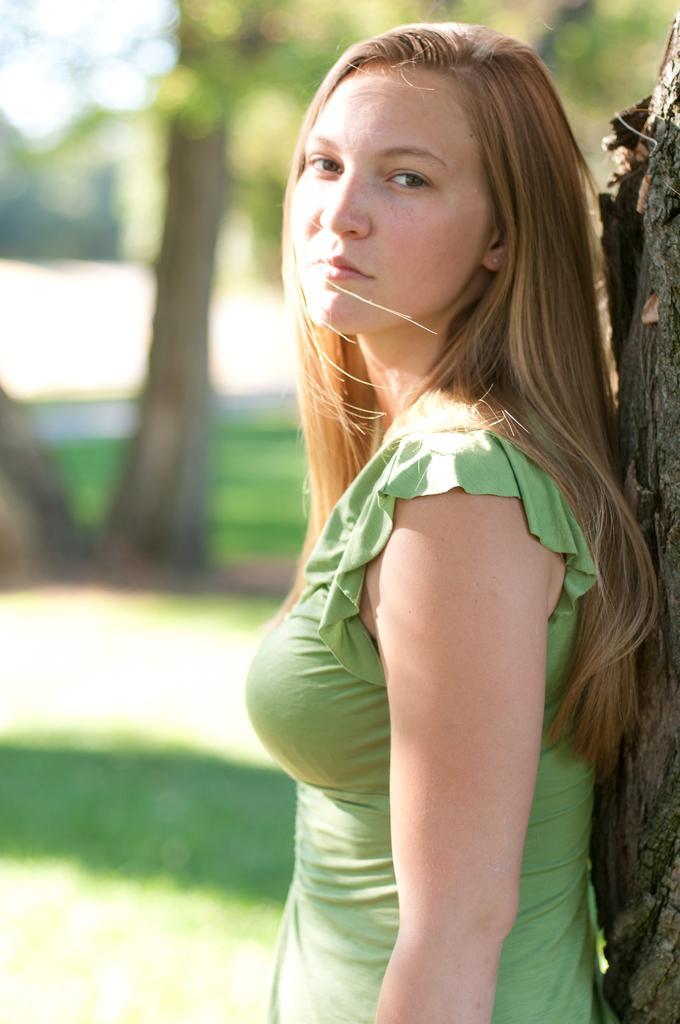How would you summarize this image in a sentence or two? In this image there is a person standing, there is a bark of the tree on the right corner. It looks like there is grass at the bottom. There are trees in the background. 